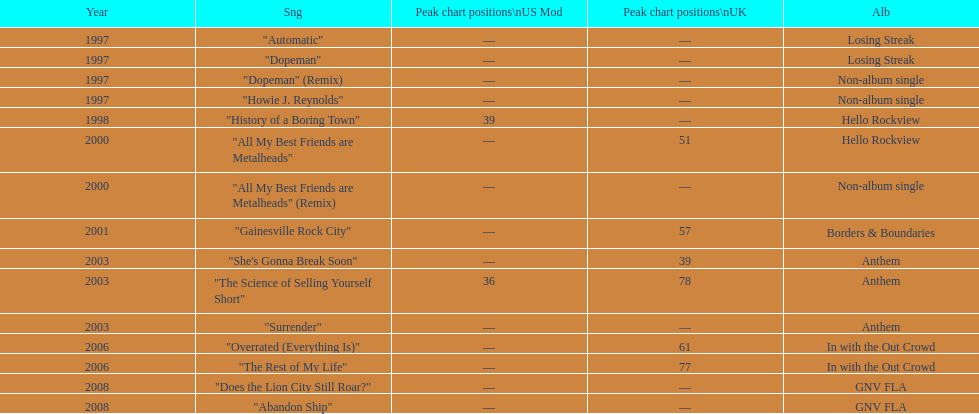Which album had the single automatic? Losing Streak. 